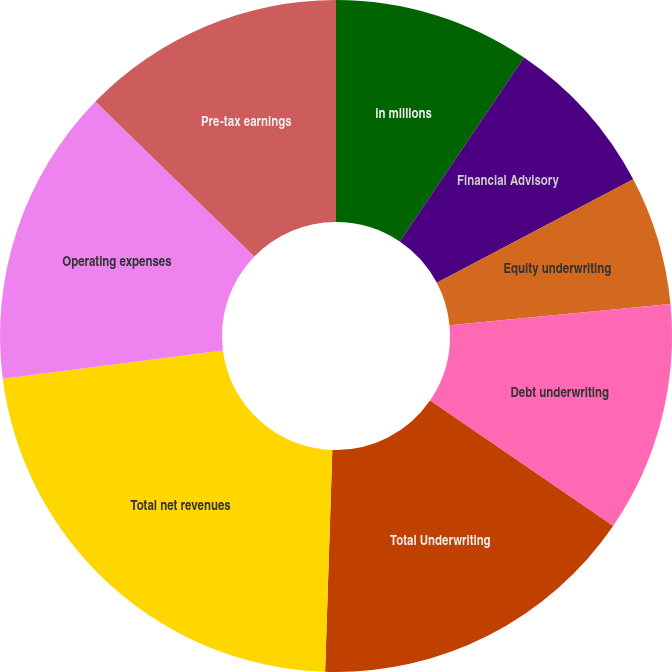Convert chart to OTSL. <chart><loc_0><loc_0><loc_500><loc_500><pie_chart><fcel>in millions<fcel>Financial Advisory<fcel>Equity underwriting<fcel>Debt underwriting<fcel>Total Underwriting<fcel>Total net revenues<fcel>Operating expenses<fcel>Pre-tax earnings<nl><fcel>9.45%<fcel>7.83%<fcel>6.2%<fcel>11.08%<fcel>15.95%<fcel>22.45%<fcel>14.33%<fcel>12.7%<nl></chart> 